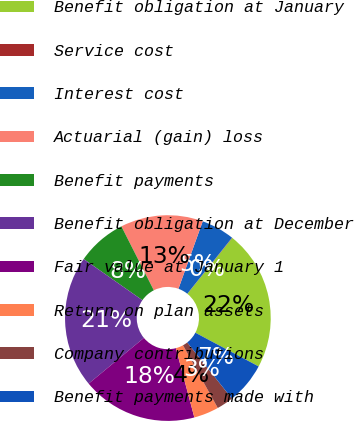<chart> <loc_0><loc_0><loc_500><loc_500><pie_chart><fcel>Benefit obligation at January<fcel>Service cost<fcel>Interest cost<fcel>Actuarial (gain) loss<fcel>Benefit payments<fcel>Benefit obligation at December<fcel>Fair value at January 1<fcel>Return on plan assets<fcel>Company contributions<fcel>Benefit payments made with<nl><fcel>22.02%<fcel>0.05%<fcel>5.22%<fcel>12.97%<fcel>7.8%<fcel>20.73%<fcel>18.14%<fcel>3.92%<fcel>2.63%<fcel>6.51%<nl></chart> 